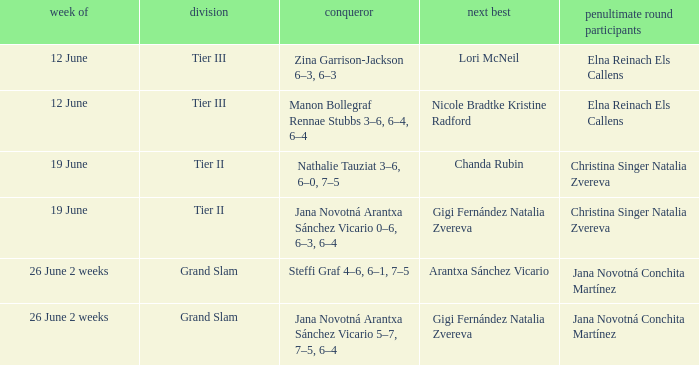When the runner-up is listed as Gigi Fernández Natalia Zvereva and the week is 26 June 2 weeks, who are the semi finalists? Jana Novotná Conchita Martínez. 